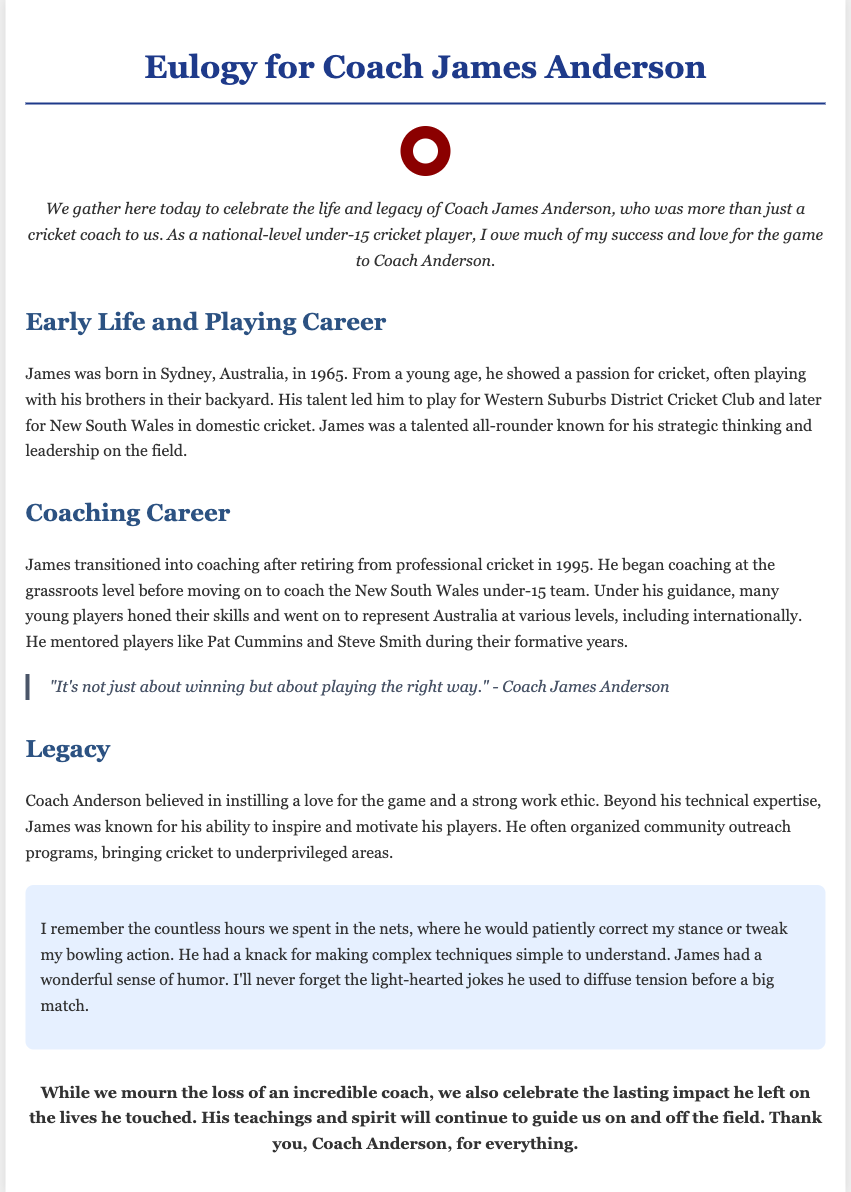What year was Coach James Anderson born? The document states that Coach James Anderson was born in 1965.
Answer: 1965 What was Coach Anderson known for as a player? The document mentions that James was a talented all-rounder known for his strategic thinking and leadership on the field.
Answer: Strategic thinking and leadership Who did Coach Anderson mentor during their formative years? The document lists Pat Cummins and Steve Smith as players mentored by James.
Answer: Pat Cummins and Steve Smith What important message did Coach Anderson emphasize? The document includes a quote from Coach Anderson that highlights it's not just about winning but about playing the right way.
Answer: Playing the right way In which team did Coach Anderson start his coaching career? According to the document, he began coaching at the grassroots level before moving on to the New South Wales under-15 team.
Answer: New South Wales under-15 team 